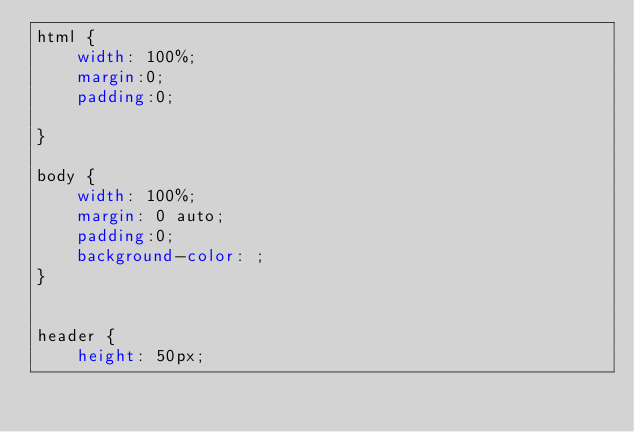<code> <loc_0><loc_0><loc_500><loc_500><_CSS_>html {
	width: 100%;
	margin:0;
	padding:0;
	
}

body {
	width: 100%;
	margin: 0 auto;
	padding:0;
	background-color: ;
}


header {
	height: 50px;</code> 